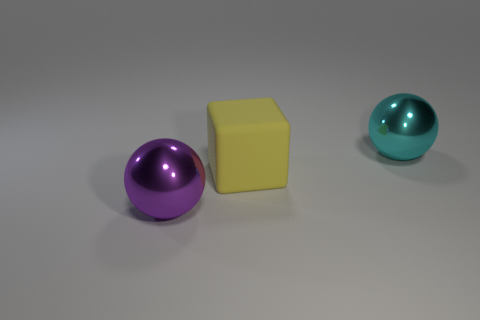Add 1 large yellow matte things. How many objects exist? 4 Subtract all cubes. How many objects are left? 2 Subtract all big matte blocks. Subtract all big cyan shiny balls. How many objects are left? 1 Add 1 cyan metallic objects. How many cyan metallic objects are left? 2 Add 3 tiny green shiny things. How many tiny green shiny things exist? 3 Subtract 0 gray spheres. How many objects are left? 3 